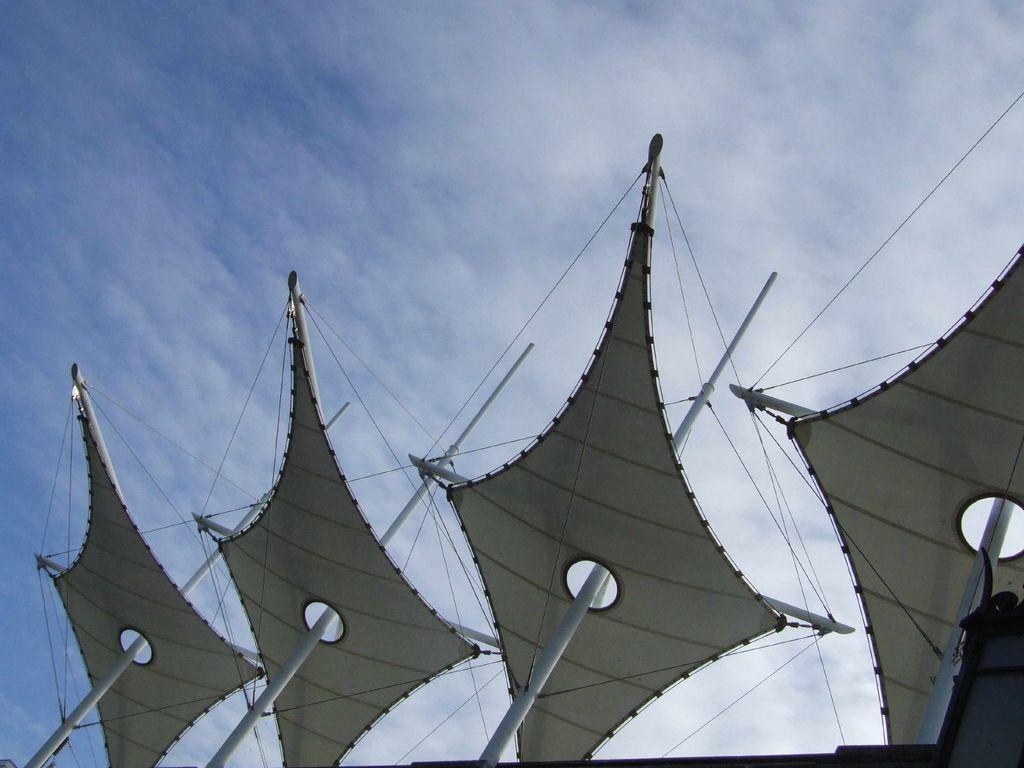What objects can be seen in the image? There are poles in the image. What is the color of the poles? The poles are white in color. What is attached to the poles? There are white cloths and wires attached to the poles. What can be seen in the background of the image? The sky is visible in the background of the image. What is the condition of the sky in the image? There are clouds in the sky. What type of cart is used to transport the sponge in the image? There is no cart or sponge present in the image. 